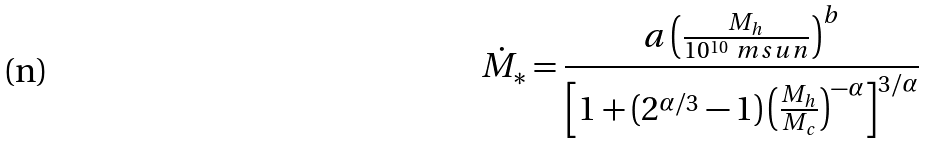Convert formula to latex. <formula><loc_0><loc_0><loc_500><loc_500>\dot { M } _ { * } = \frac { a \left ( \frac { M _ { h } } { 1 0 ^ { 1 0 } \ m s u n } \right ) ^ { b } } { \left [ 1 + ( 2 ^ { \alpha / 3 } - 1 ) \left ( \frac { M _ { h } } { M _ { c } } \right ) ^ { - \alpha } \right ] ^ { 3 / \alpha } }</formula> 